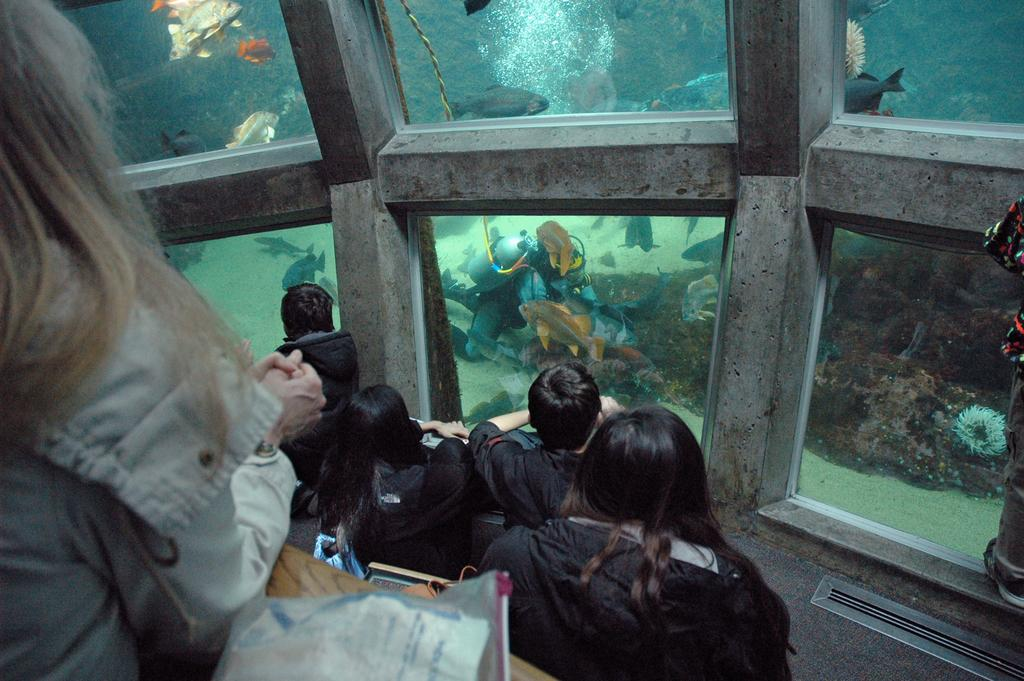How many people can be seen in the image? There are many people in the image. What type of walls are present in the image? There are glass walls in the image. What can be seen through the glass walls? Fishes are visible through the glass walls. What is the primary liquid element in the image? There is water in the image. Is there a person interacting with the water? Yes, there is a person in the water. What type of underwater vegetation or structure is present in the image? Coral is present in the image. What type of birthday celebration is taking place in the image? There is no indication of a birthday celebration in the image. How many brothers are visible in the image? There is no mention of brothers in the image. 